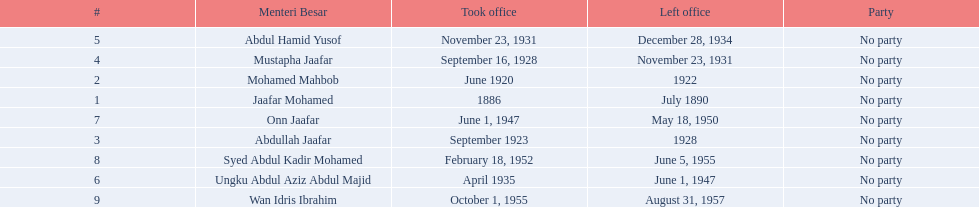Who spend the most amount of time in office? Ungku Abdul Aziz Abdul Majid. Write the full table. {'header': ['#', 'Menteri Besar', 'Took office', 'Left office', 'Party'], 'rows': [['5', 'Abdul Hamid Yusof', 'November 23, 1931', 'December 28, 1934', 'No party'], ['4', 'Mustapha Jaafar', 'September 16, 1928', 'November 23, 1931', 'No party'], ['2', 'Mohamed Mahbob', 'June 1920', '1922', 'No party'], ['1', 'Jaafar Mohamed', '1886', 'July 1890', 'No party'], ['7', 'Onn Jaafar', 'June 1, 1947', 'May 18, 1950', 'No party'], ['3', 'Abdullah Jaafar', 'September 1923', '1928', 'No party'], ['8', 'Syed Abdul Kadir Mohamed', 'February 18, 1952', 'June 5, 1955', 'No party'], ['6', 'Ungku Abdul Aziz Abdul Majid', 'April 1935', 'June 1, 1947', 'No party'], ['9', 'Wan Idris Ibrahim', 'October 1, 1955', 'August 31, 1957', 'No party']]} 